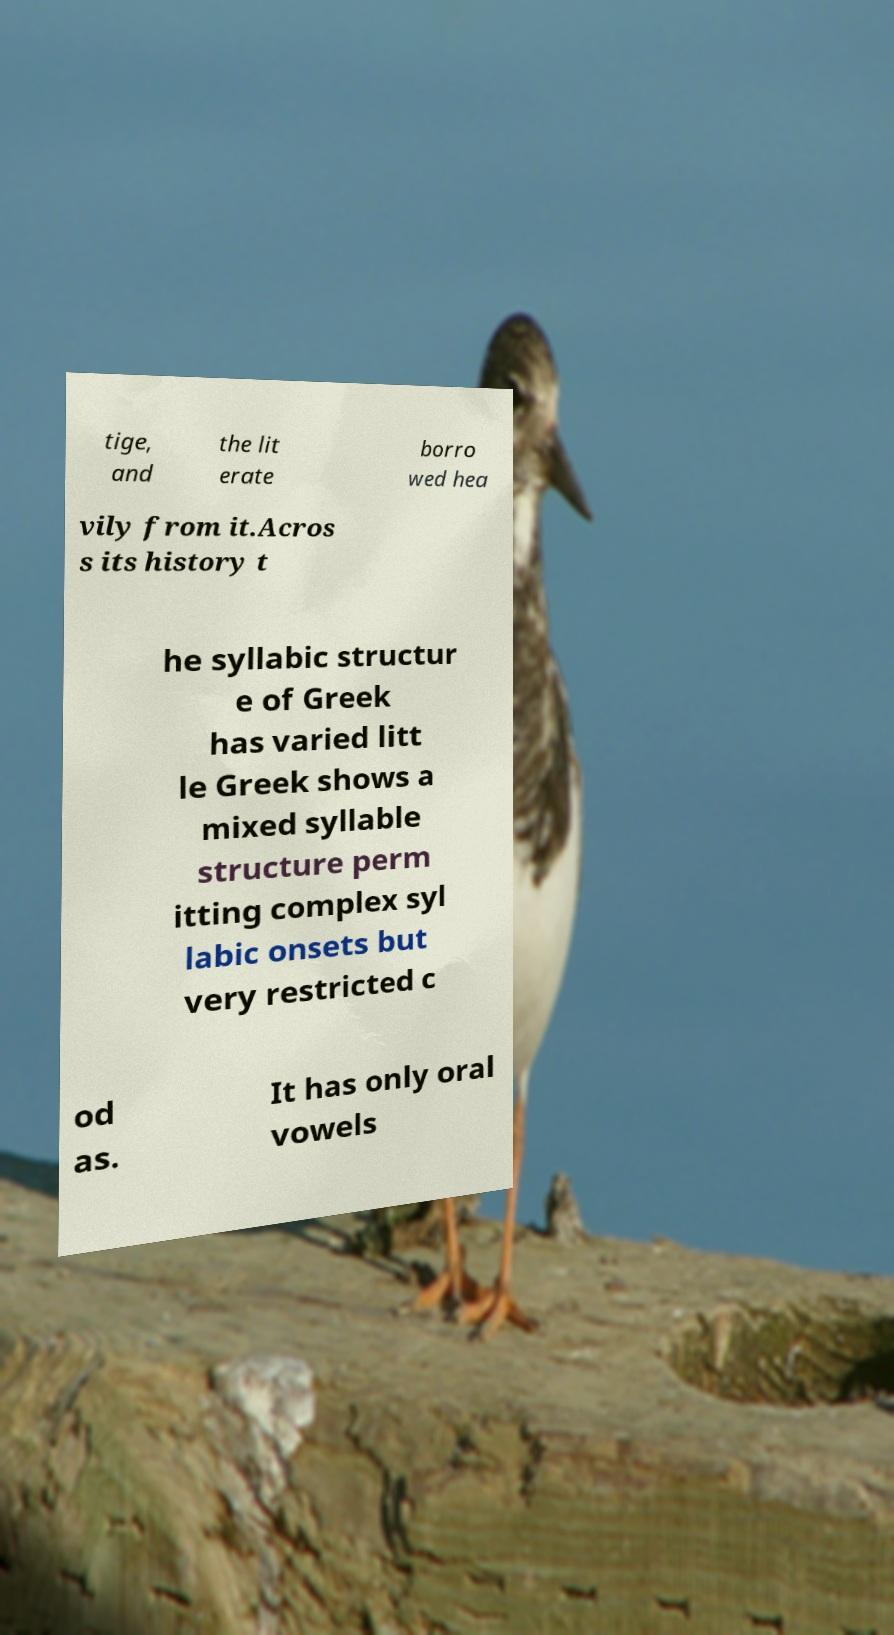What messages or text are displayed in this image? I need them in a readable, typed format. tige, and the lit erate borro wed hea vily from it.Acros s its history t he syllabic structur e of Greek has varied litt le Greek shows a mixed syllable structure perm itting complex syl labic onsets but very restricted c od as. It has only oral vowels 